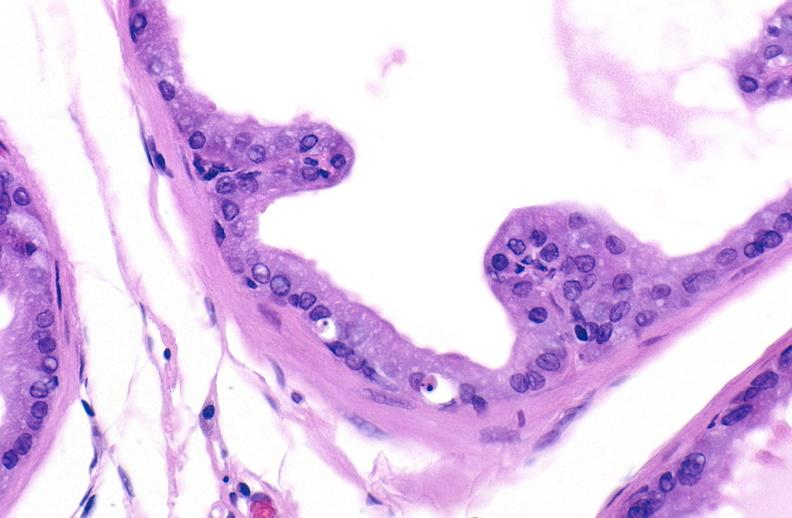does this image show apoptosis in prostate after orchiectomy?
Answer the question using a single word or phrase. Yes 